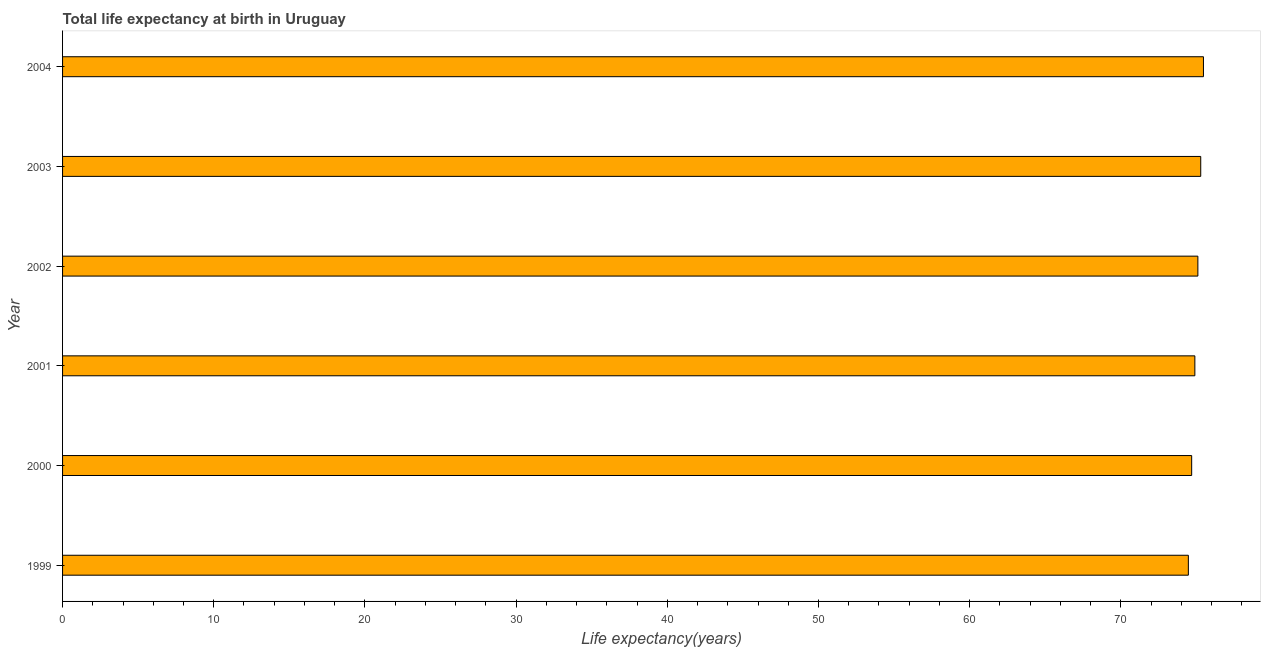What is the title of the graph?
Provide a short and direct response. Total life expectancy at birth in Uruguay. What is the label or title of the X-axis?
Provide a short and direct response. Life expectancy(years). What is the label or title of the Y-axis?
Your answer should be compact. Year. What is the life expectancy at birth in 2002?
Keep it short and to the point. 75.1. Across all years, what is the maximum life expectancy at birth?
Your response must be concise. 75.46. Across all years, what is the minimum life expectancy at birth?
Your response must be concise. 74.47. In which year was the life expectancy at birth minimum?
Offer a terse response. 1999. What is the sum of the life expectancy at birth?
Your answer should be very brief. 449.89. What is the difference between the life expectancy at birth in 1999 and 2003?
Make the answer very short. -0.82. What is the average life expectancy at birth per year?
Offer a very short reply. 74.98. What is the median life expectancy at birth?
Your answer should be very brief. 75. In how many years, is the life expectancy at birth greater than 42 years?
Give a very brief answer. 6. Do a majority of the years between 2002 and 1999 (inclusive) have life expectancy at birth greater than 14 years?
Offer a terse response. Yes. What is the ratio of the life expectancy at birth in 2000 to that in 2002?
Provide a short and direct response. 0.99. Is the difference between the life expectancy at birth in 1999 and 2001 greater than the difference between any two years?
Provide a succinct answer. No. What is the difference between the highest and the second highest life expectancy at birth?
Keep it short and to the point. 0.18. In how many years, is the life expectancy at birth greater than the average life expectancy at birth taken over all years?
Your answer should be very brief. 3. How many bars are there?
Offer a terse response. 6. How many years are there in the graph?
Provide a short and direct response. 6. What is the difference between two consecutive major ticks on the X-axis?
Provide a succinct answer. 10. What is the Life expectancy(years) in 1999?
Ensure brevity in your answer.  74.47. What is the Life expectancy(years) in 2000?
Make the answer very short. 74.69. What is the Life expectancy(years) in 2001?
Provide a succinct answer. 74.9. What is the Life expectancy(years) of 2002?
Offer a very short reply. 75.1. What is the Life expectancy(years) of 2003?
Provide a short and direct response. 75.28. What is the Life expectancy(years) of 2004?
Offer a terse response. 75.46. What is the difference between the Life expectancy(years) in 1999 and 2000?
Your response must be concise. -0.22. What is the difference between the Life expectancy(years) in 1999 and 2001?
Provide a short and direct response. -0.43. What is the difference between the Life expectancy(years) in 1999 and 2002?
Ensure brevity in your answer.  -0.63. What is the difference between the Life expectancy(years) in 1999 and 2003?
Ensure brevity in your answer.  -0.82. What is the difference between the Life expectancy(years) in 1999 and 2004?
Make the answer very short. -1. What is the difference between the Life expectancy(years) in 2000 and 2001?
Offer a terse response. -0.21. What is the difference between the Life expectancy(years) in 2000 and 2002?
Provide a succinct answer. -0.41. What is the difference between the Life expectancy(years) in 2000 and 2003?
Keep it short and to the point. -0.6. What is the difference between the Life expectancy(years) in 2000 and 2004?
Provide a succinct answer. -0.78. What is the difference between the Life expectancy(years) in 2001 and 2002?
Your response must be concise. -0.2. What is the difference between the Life expectancy(years) in 2001 and 2003?
Make the answer very short. -0.39. What is the difference between the Life expectancy(years) in 2001 and 2004?
Ensure brevity in your answer.  -0.57. What is the difference between the Life expectancy(years) in 2002 and 2003?
Your answer should be very brief. -0.19. What is the difference between the Life expectancy(years) in 2002 and 2004?
Offer a very short reply. -0.37. What is the difference between the Life expectancy(years) in 2003 and 2004?
Your answer should be very brief. -0.18. What is the ratio of the Life expectancy(years) in 1999 to that in 2000?
Keep it short and to the point. 1. What is the ratio of the Life expectancy(years) in 1999 to that in 2002?
Offer a terse response. 0.99. What is the ratio of the Life expectancy(years) in 1999 to that in 2004?
Make the answer very short. 0.99. What is the ratio of the Life expectancy(years) in 2000 to that in 2002?
Your answer should be compact. 0.99. What is the ratio of the Life expectancy(years) in 2000 to that in 2003?
Provide a succinct answer. 0.99. What is the ratio of the Life expectancy(years) in 2001 to that in 2003?
Offer a terse response. 0.99. What is the ratio of the Life expectancy(years) in 2001 to that in 2004?
Keep it short and to the point. 0.99. What is the ratio of the Life expectancy(years) in 2002 to that in 2003?
Give a very brief answer. 1. What is the ratio of the Life expectancy(years) in 2002 to that in 2004?
Keep it short and to the point. 0.99. 